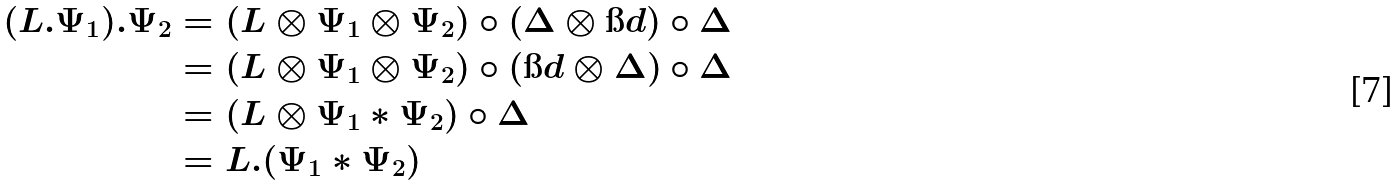<formula> <loc_0><loc_0><loc_500><loc_500>( L . \Psi _ { 1 } ) . \Psi _ { 2 } & = ( L \otimes \Psi _ { 1 } \otimes \Psi _ { 2 } ) \circ ( \Delta \otimes { \i d } ) \circ \Delta \\ & = ( L \otimes \Psi _ { 1 } \otimes \Psi _ { 2 } ) \circ ( { \i d } \otimes \Delta ) \circ \Delta \\ & = ( L \otimes \Psi _ { 1 } * \Psi _ { 2 } ) \circ \Delta \\ & = L . ( \Psi _ { 1 } * \Psi _ { 2 } )</formula> 